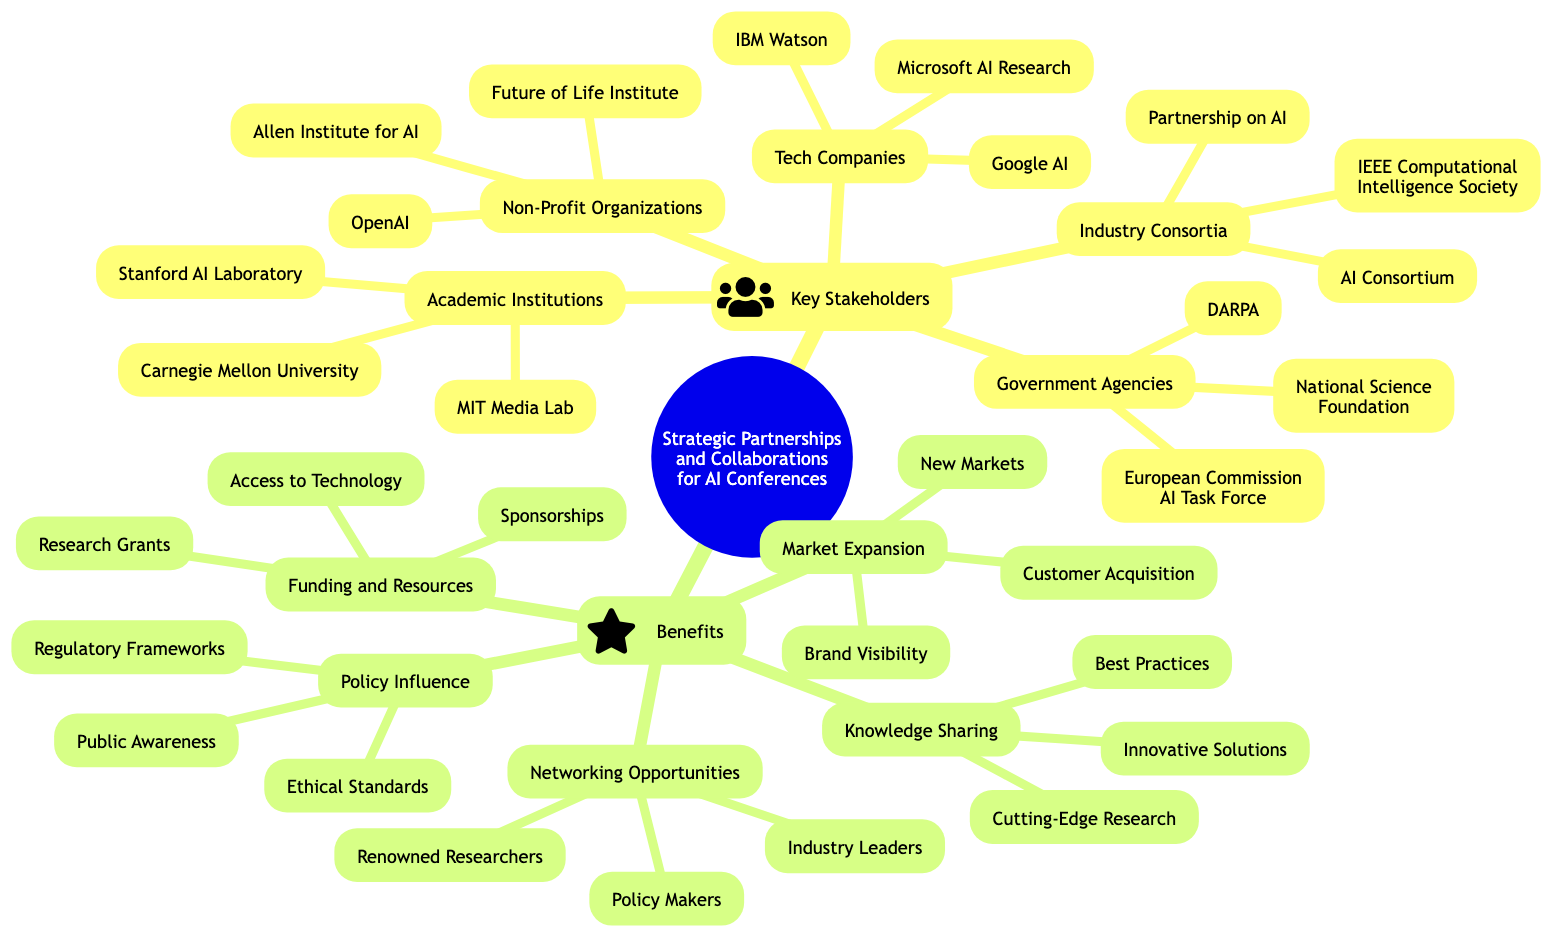What are the key stakeholders for AI conferences? The central concept branches into two main categories: Key Stakeholders and Benefits. Under Key Stakeholders, various entities are listed, including Academic Institutions, Tech Companies, Industry Consortia, Government Agencies, and Non-Profit Organizations.
Answer: Academic Institutions, Tech Companies, Industry Consortia, Government Agencies, Non-Profit Organizations How many academic institutions are listed? The Key Stakeholders branch contains a subbranch for Academic Institutions, which includes three specific entities: MIT Media Lab, Stanford Artificial Intelligence Laboratory, and Carnegie Mellon University. Thus, by counting these, we find there are a total of three institutions.
Answer: 3 Which tech company is mentioned first? The Tech Companies subbranch is listed under Key Stakeholders. The first specific entity mentioned under that subbranch is Google AI.
Answer: Google AI What benefit is associated with Knowledge Sharing? Under the Benefits branch, Knowledge Sharing has three subbranches. The first one listed is Cutting-Edge Research, which directly associates this benefit with that specific subbranch.
Answer: Cutting-Edge Research How many benefits are outlined in the diagram? The Benefits branch contains a total of five subbranches: Knowledge Sharing, Networking Opportunities, Funding and Resources, Market Expansion, and Policy Influence. Counting these gives us the total number of outlined benefits.
Answer: 5 Which organization related to International AI is identified under government agencies? The Government Agencies subbranch has several entities, one being the European Commission AI Task Force, specifically mentioned as related to international AI efforts.
Answer: European Commission AI Task Force What is a benefit related to Market Expansion? Market Expansion benefits include three key aspects: New Markets, Customer Acquisition, and Brand Visibility. The first benefit listed in this category is New Markets, indicating its relevance.
Answer: New Markets How many non-profit organizations are named? The Non-Profit Organizations subbranch includes three specific entities: OpenAI, Allen Institute for AI, and Future of Life Institute. Counting these provides the total number of organizations identified.
Answer: 3 